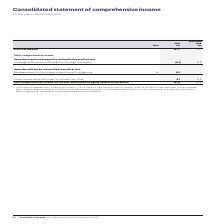According to Auto Trader's financial document, Which IFRS standard(s) did the Group adopt? IFRS 9 ‘Financial Instruments’, IFRS 15 ‘Revenue from Contracts with Customers’, and IFRS 16 ‘Leases’ from 1 April 2018. The document states: "1 The Group has adopted IFRS 9 ‘Financial Instruments’, IFRS 15 ‘Revenue from Contracts with Customers’, and IFRS 16 ‘Leases’ from 1 April 2018. The y..." Also, What have the values in the 2018 column been restated for? for IFRS 16 which was implemented using the fully retrospective method. The document states: "8. The year ended 31 March 2018 has been restated for IFRS 16 which was implemented using the fully retrospective method. For further information on t..." Also, In which years was Profit for the year calculated in the Consolidated statement of comprehensive income? The document shows two values: 2019 and 2018. From the document: "Group plc Annual Report and Financial Statements 2019 (Restated) 1 2018 £m..." Additionally, In which year was Profit for the year larger? According to the financial document, 2019. The relevant text states: "Group plc Annual Report and Financial Statements 2019..." Also, can you calculate: What was the change in profit for the year in 2019 from 2018? Based on the calculation: 197.7-171.1, the result is 26.6 (in millions). This is based on the information: "Profit for the year 197.7 171.1 Profit for the year 197.7 171.1..." The key data points involved are: 171.1, 197.7. Also, can you calculate: What was the percentage change in profit for the year in 2019 from 2018? To answer this question, I need to perform calculations using the financial data. The calculation is: (197.7-171.1)/171.1, which equals 15.55 (percentage). This is based on the information: "Profit for the year 197.7 171.1 Profit for the year 197.7 171.1..." The key data points involved are: 171.1, 197.7. 